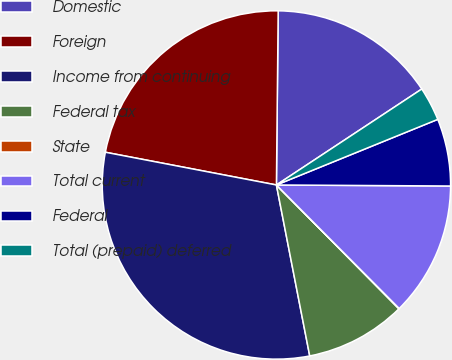Convert chart to OTSL. <chart><loc_0><loc_0><loc_500><loc_500><pie_chart><fcel>Domestic<fcel>Foreign<fcel>Income from continuing<fcel>Federal tax<fcel>State<fcel>Total current<fcel>Federal<fcel>Total (prepaid) deferred<nl><fcel>15.55%<fcel>22.15%<fcel>31.07%<fcel>9.35%<fcel>0.04%<fcel>12.45%<fcel>6.24%<fcel>3.14%<nl></chart> 